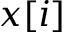<formula> <loc_0><loc_0><loc_500><loc_500>x [ i ]</formula> 